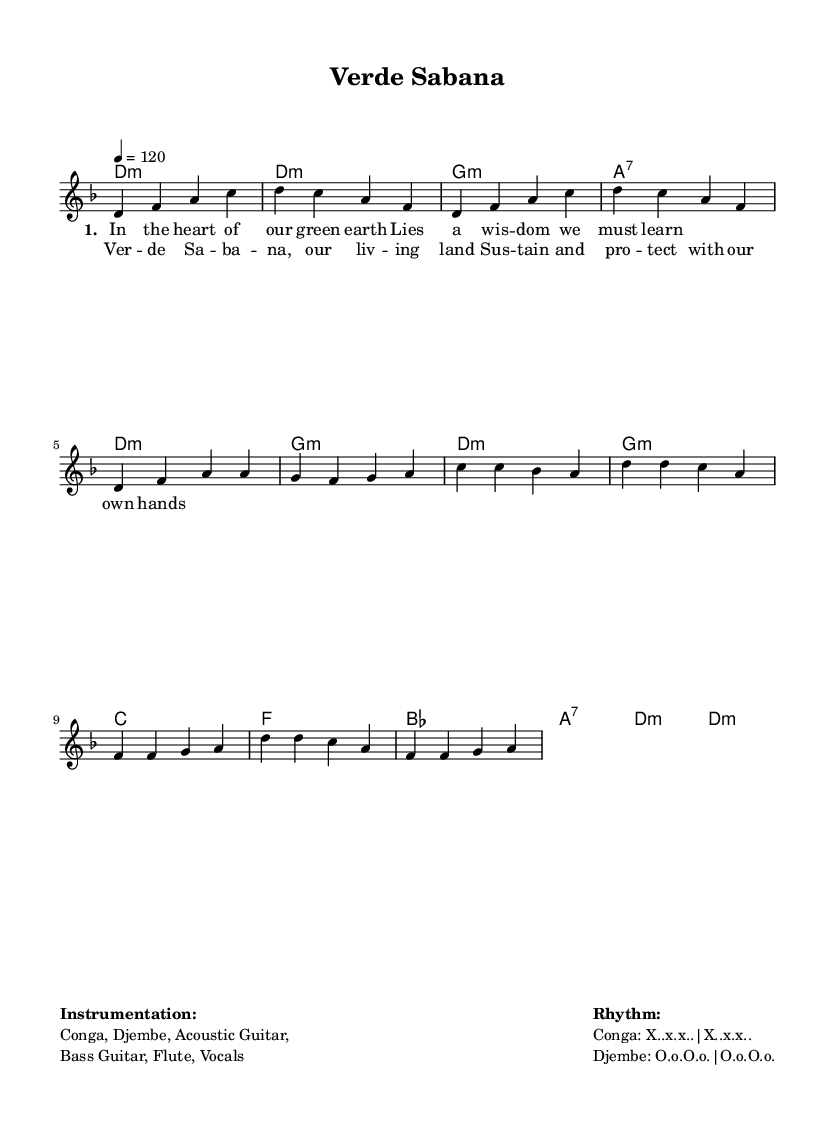What is the key signature of this music? The key signature is D minor, which has one flat (B flat). This can be identified by looking at the left side of the staff where the key signature is notated.
Answer: D minor What is the time signature of this music? The time signature is 4/4, indicating four beats per measure with a quarter note receiving one beat. This can be found at the beginning of the score before the first measure.
Answer: 4/4 What is the tempo marking of this music? The tempo marking is 120 beats per minute, which is indicated by the "tempo 4 = 120" notation in the global settings section.
Answer: 120 How many measures are in the verse section? There are six measures in the verse section, counted by observing the number of sequences separating the lyric lines set in "verse" under the \lyricmode.
Answer: 6 What is the main rhythmic instrument used in the composition? The primary rhythmic instrument is the Conga, as noted in the instrumentation section that lists "Conga, Djembe, Acoustic Guitar, Bass Guitar, Flute, Vocals". This is a common instrument in Latin rhythms.
Answer: Conga Which chord appears most frequently in the score? The chord D minor appears most frequently in the score, as it is stated in multiple places during the intro and throughout the chorus section. This can be ascertained by scanning through the harmonies in the chord mode.
Answer: D minor What thematic message does the chorus convey? The chorus conveys a message of sustainability and protection of the environment, as expressed through the lyrics which urge to "sustain and protect with our own hands". The connection to eco-consciousness is implied through these words.
Answer: Sustain and protect 